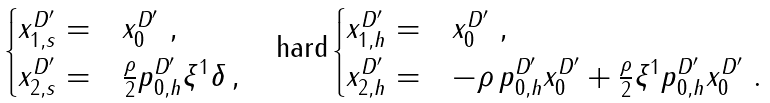Convert formula to latex. <formula><loc_0><loc_0><loc_500><loc_500>\begin{cases} x _ { 1 , s } ^ { D ^ { \prime } } = & x _ { 0 } ^ { D ^ { \prime } } \ , \\ x _ { 2 , s } ^ { D ^ { \prime } } = & \frac { \rho } { 2 } p _ { 0 , h } ^ { D ^ { \prime } } \xi ^ { 1 } \delta \, , \end{cases} \quad \text {hard} \begin{cases} x _ { 1 , h } ^ { D ^ { \prime } } = & x _ { 0 } ^ { D ^ { \prime } } \ , \\ x _ { 2 , h } ^ { D ^ { \prime } } = & - \rho \, p ^ { D ^ { \prime } } _ { 0 , h } x _ { 0 } ^ { D ^ { \prime } } + \frac { \rho } { 2 } \xi ^ { 1 } p _ { 0 , h } ^ { D ^ { \prime } } x _ { 0 } ^ { D ^ { \prime } } \ . \end{cases}</formula> 